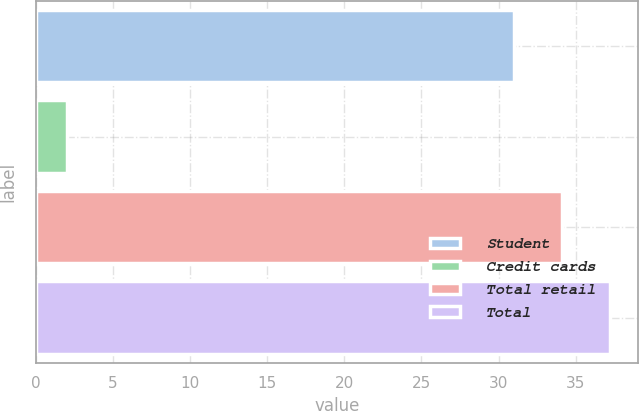Convert chart. <chart><loc_0><loc_0><loc_500><loc_500><bar_chart><fcel>Student<fcel>Credit cards<fcel>Total retail<fcel>Total<nl><fcel>31<fcel>2<fcel>34.1<fcel>37.2<nl></chart> 